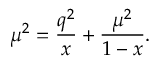<formula> <loc_0><loc_0><loc_500><loc_500>\mu ^ { 2 } = \frac { q ^ { 2 } } { x } + \frac { \mu ^ { 2 } } { 1 - x } .</formula> 